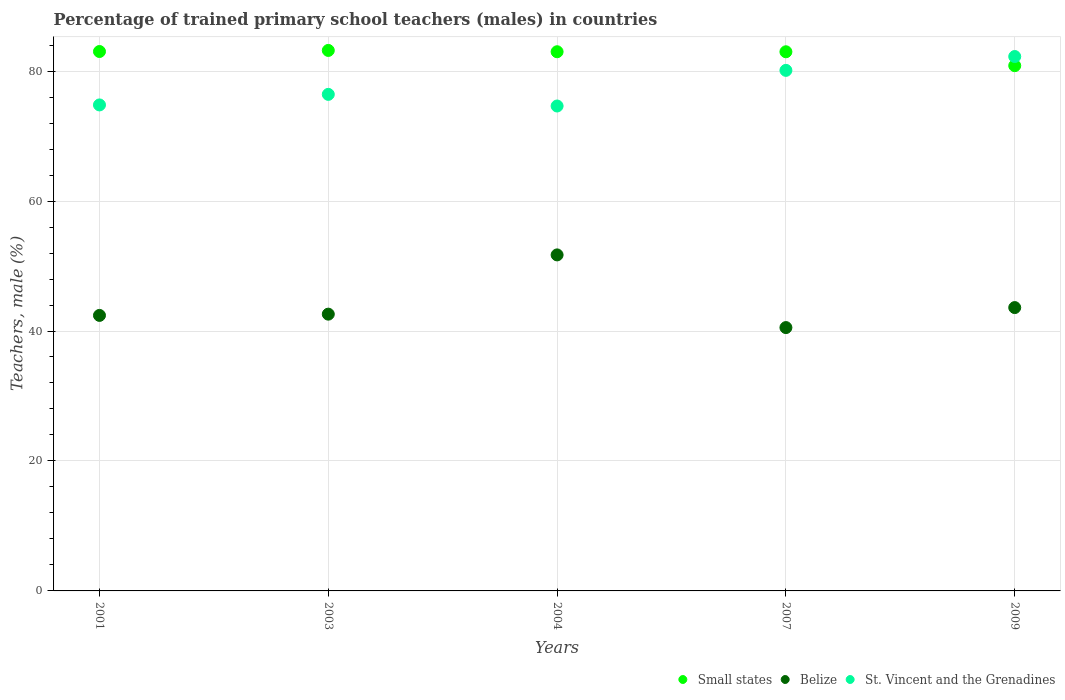Is the number of dotlines equal to the number of legend labels?
Your answer should be very brief. Yes. What is the percentage of trained primary school teachers (males) in Belize in 2001?
Keep it short and to the point. 42.4. Across all years, what is the maximum percentage of trained primary school teachers (males) in Belize?
Your answer should be very brief. 51.71. Across all years, what is the minimum percentage of trained primary school teachers (males) in St. Vincent and the Grenadines?
Offer a terse response. 74.63. In which year was the percentage of trained primary school teachers (males) in St. Vincent and the Grenadines maximum?
Give a very brief answer. 2009. What is the total percentage of trained primary school teachers (males) in St. Vincent and the Grenadines in the graph?
Your answer should be very brief. 388.19. What is the difference between the percentage of trained primary school teachers (males) in Small states in 2003 and that in 2007?
Your response must be concise. 0.21. What is the difference between the percentage of trained primary school teachers (males) in St. Vincent and the Grenadines in 2003 and the percentage of trained primary school teachers (males) in Belize in 2007?
Your response must be concise. 35.89. What is the average percentage of trained primary school teachers (males) in Small states per year?
Offer a terse response. 82.6. In the year 2003, what is the difference between the percentage of trained primary school teachers (males) in Small states and percentage of trained primary school teachers (males) in Belize?
Your answer should be very brief. 40.59. What is the ratio of the percentage of trained primary school teachers (males) in Small states in 2004 to that in 2009?
Ensure brevity in your answer.  1.03. Is the difference between the percentage of trained primary school teachers (males) in Small states in 2003 and 2004 greater than the difference between the percentage of trained primary school teachers (males) in Belize in 2003 and 2004?
Your answer should be compact. Yes. What is the difference between the highest and the second highest percentage of trained primary school teachers (males) in Belize?
Offer a terse response. 8.11. What is the difference between the highest and the lowest percentage of trained primary school teachers (males) in Belize?
Provide a short and direct response. 11.19. In how many years, is the percentage of trained primary school teachers (males) in Small states greater than the average percentage of trained primary school teachers (males) in Small states taken over all years?
Provide a short and direct response. 4. Is the percentage of trained primary school teachers (males) in Small states strictly greater than the percentage of trained primary school teachers (males) in Belize over the years?
Keep it short and to the point. Yes. How many dotlines are there?
Offer a very short reply. 3. How many years are there in the graph?
Keep it short and to the point. 5. What is the difference between two consecutive major ticks on the Y-axis?
Give a very brief answer. 20. What is the title of the graph?
Keep it short and to the point. Percentage of trained primary school teachers (males) in countries. What is the label or title of the X-axis?
Provide a succinct answer. Years. What is the label or title of the Y-axis?
Ensure brevity in your answer.  Teachers, male (%). What is the Teachers, male (%) in Small states in 2001?
Make the answer very short. 83.01. What is the Teachers, male (%) of Belize in 2001?
Your answer should be compact. 42.4. What is the Teachers, male (%) of St. Vincent and the Grenadines in 2001?
Ensure brevity in your answer.  74.79. What is the Teachers, male (%) of Small states in 2003?
Offer a very short reply. 83.18. What is the Teachers, male (%) in Belize in 2003?
Make the answer very short. 42.59. What is the Teachers, male (%) of St. Vincent and the Grenadines in 2003?
Make the answer very short. 76.42. What is the Teachers, male (%) of Small states in 2004?
Keep it short and to the point. 82.98. What is the Teachers, male (%) of Belize in 2004?
Make the answer very short. 51.71. What is the Teachers, male (%) in St. Vincent and the Grenadines in 2004?
Provide a succinct answer. 74.63. What is the Teachers, male (%) in Small states in 2007?
Provide a short and direct response. 82.97. What is the Teachers, male (%) in Belize in 2007?
Keep it short and to the point. 40.53. What is the Teachers, male (%) of St. Vincent and the Grenadines in 2007?
Give a very brief answer. 80.11. What is the Teachers, male (%) of Small states in 2009?
Your response must be concise. 80.84. What is the Teachers, male (%) in Belize in 2009?
Make the answer very short. 43.6. What is the Teachers, male (%) of St. Vincent and the Grenadines in 2009?
Provide a short and direct response. 82.24. Across all years, what is the maximum Teachers, male (%) of Small states?
Provide a short and direct response. 83.18. Across all years, what is the maximum Teachers, male (%) in Belize?
Your answer should be very brief. 51.71. Across all years, what is the maximum Teachers, male (%) in St. Vincent and the Grenadines?
Your answer should be very brief. 82.24. Across all years, what is the minimum Teachers, male (%) of Small states?
Offer a very short reply. 80.84. Across all years, what is the minimum Teachers, male (%) of Belize?
Your response must be concise. 40.53. Across all years, what is the minimum Teachers, male (%) of St. Vincent and the Grenadines?
Your response must be concise. 74.63. What is the total Teachers, male (%) in Small states in the graph?
Your answer should be compact. 412.98. What is the total Teachers, male (%) of Belize in the graph?
Make the answer very short. 220.84. What is the total Teachers, male (%) in St. Vincent and the Grenadines in the graph?
Make the answer very short. 388.19. What is the difference between the Teachers, male (%) of Small states in 2001 and that in 2003?
Ensure brevity in your answer.  -0.17. What is the difference between the Teachers, male (%) in Belize in 2001 and that in 2003?
Your answer should be compact. -0.19. What is the difference between the Teachers, male (%) in St. Vincent and the Grenadines in 2001 and that in 2003?
Your answer should be very brief. -1.62. What is the difference between the Teachers, male (%) of Small states in 2001 and that in 2004?
Your answer should be very brief. 0.04. What is the difference between the Teachers, male (%) of Belize in 2001 and that in 2004?
Give a very brief answer. -9.31. What is the difference between the Teachers, male (%) of St. Vincent and the Grenadines in 2001 and that in 2004?
Offer a very short reply. 0.17. What is the difference between the Teachers, male (%) in Small states in 2001 and that in 2007?
Provide a succinct answer. 0.04. What is the difference between the Teachers, male (%) in Belize in 2001 and that in 2007?
Offer a very short reply. 1.87. What is the difference between the Teachers, male (%) of St. Vincent and the Grenadines in 2001 and that in 2007?
Make the answer very short. -5.32. What is the difference between the Teachers, male (%) of Small states in 2001 and that in 2009?
Keep it short and to the point. 2.18. What is the difference between the Teachers, male (%) of Belize in 2001 and that in 2009?
Your answer should be very brief. -1.2. What is the difference between the Teachers, male (%) of St. Vincent and the Grenadines in 2001 and that in 2009?
Make the answer very short. -7.45. What is the difference between the Teachers, male (%) in Small states in 2003 and that in 2004?
Ensure brevity in your answer.  0.2. What is the difference between the Teachers, male (%) of Belize in 2003 and that in 2004?
Ensure brevity in your answer.  -9.12. What is the difference between the Teachers, male (%) of St. Vincent and the Grenadines in 2003 and that in 2004?
Give a very brief answer. 1.79. What is the difference between the Teachers, male (%) of Small states in 2003 and that in 2007?
Keep it short and to the point. 0.21. What is the difference between the Teachers, male (%) of Belize in 2003 and that in 2007?
Your response must be concise. 2.07. What is the difference between the Teachers, male (%) in St. Vincent and the Grenadines in 2003 and that in 2007?
Offer a terse response. -3.69. What is the difference between the Teachers, male (%) in Small states in 2003 and that in 2009?
Offer a terse response. 2.34. What is the difference between the Teachers, male (%) in Belize in 2003 and that in 2009?
Your response must be concise. -1.01. What is the difference between the Teachers, male (%) in St. Vincent and the Grenadines in 2003 and that in 2009?
Provide a short and direct response. -5.82. What is the difference between the Teachers, male (%) in Small states in 2004 and that in 2007?
Your response must be concise. 0. What is the difference between the Teachers, male (%) of Belize in 2004 and that in 2007?
Make the answer very short. 11.19. What is the difference between the Teachers, male (%) of St. Vincent and the Grenadines in 2004 and that in 2007?
Offer a very short reply. -5.48. What is the difference between the Teachers, male (%) of Small states in 2004 and that in 2009?
Offer a very short reply. 2.14. What is the difference between the Teachers, male (%) in Belize in 2004 and that in 2009?
Make the answer very short. 8.11. What is the difference between the Teachers, male (%) of St. Vincent and the Grenadines in 2004 and that in 2009?
Your answer should be very brief. -7.61. What is the difference between the Teachers, male (%) in Small states in 2007 and that in 2009?
Make the answer very short. 2.14. What is the difference between the Teachers, male (%) of Belize in 2007 and that in 2009?
Ensure brevity in your answer.  -3.08. What is the difference between the Teachers, male (%) of St. Vincent and the Grenadines in 2007 and that in 2009?
Make the answer very short. -2.13. What is the difference between the Teachers, male (%) of Small states in 2001 and the Teachers, male (%) of Belize in 2003?
Make the answer very short. 40.42. What is the difference between the Teachers, male (%) in Small states in 2001 and the Teachers, male (%) in St. Vincent and the Grenadines in 2003?
Give a very brief answer. 6.6. What is the difference between the Teachers, male (%) in Belize in 2001 and the Teachers, male (%) in St. Vincent and the Grenadines in 2003?
Offer a very short reply. -34.02. What is the difference between the Teachers, male (%) of Small states in 2001 and the Teachers, male (%) of Belize in 2004?
Your response must be concise. 31.3. What is the difference between the Teachers, male (%) in Small states in 2001 and the Teachers, male (%) in St. Vincent and the Grenadines in 2004?
Ensure brevity in your answer.  8.39. What is the difference between the Teachers, male (%) of Belize in 2001 and the Teachers, male (%) of St. Vincent and the Grenadines in 2004?
Keep it short and to the point. -32.23. What is the difference between the Teachers, male (%) in Small states in 2001 and the Teachers, male (%) in Belize in 2007?
Give a very brief answer. 42.49. What is the difference between the Teachers, male (%) of Small states in 2001 and the Teachers, male (%) of St. Vincent and the Grenadines in 2007?
Offer a very short reply. 2.9. What is the difference between the Teachers, male (%) in Belize in 2001 and the Teachers, male (%) in St. Vincent and the Grenadines in 2007?
Provide a succinct answer. -37.71. What is the difference between the Teachers, male (%) of Small states in 2001 and the Teachers, male (%) of Belize in 2009?
Make the answer very short. 39.41. What is the difference between the Teachers, male (%) in Small states in 2001 and the Teachers, male (%) in St. Vincent and the Grenadines in 2009?
Ensure brevity in your answer.  0.77. What is the difference between the Teachers, male (%) in Belize in 2001 and the Teachers, male (%) in St. Vincent and the Grenadines in 2009?
Keep it short and to the point. -39.84. What is the difference between the Teachers, male (%) of Small states in 2003 and the Teachers, male (%) of Belize in 2004?
Provide a short and direct response. 31.47. What is the difference between the Teachers, male (%) in Small states in 2003 and the Teachers, male (%) in St. Vincent and the Grenadines in 2004?
Your answer should be very brief. 8.55. What is the difference between the Teachers, male (%) of Belize in 2003 and the Teachers, male (%) of St. Vincent and the Grenadines in 2004?
Your response must be concise. -32.03. What is the difference between the Teachers, male (%) in Small states in 2003 and the Teachers, male (%) in Belize in 2007?
Your answer should be compact. 42.65. What is the difference between the Teachers, male (%) of Small states in 2003 and the Teachers, male (%) of St. Vincent and the Grenadines in 2007?
Your answer should be very brief. 3.07. What is the difference between the Teachers, male (%) of Belize in 2003 and the Teachers, male (%) of St. Vincent and the Grenadines in 2007?
Provide a succinct answer. -37.52. What is the difference between the Teachers, male (%) of Small states in 2003 and the Teachers, male (%) of Belize in 2009?
Keep it short and to the point. 39.57. What is the difference between the Teachers, male (%) of Small states in 2003 and the Teachers, male (%) of St. Vincent and the Grenadines in 2009?
Give a very brief answer. 0.94. What is the difference between the Teachers, male (%) in Belize in 2003 and the Teachers, male (%) in St. Vincent and the Grenadines in 2009?
Give a very brief answer. -39.65. What is the difference between the Teachers, male (%) of Small states in 2004 and the Teachers, male (%) of Belize in 2007?
Your answer should be compact. 42.45. What is the difference between the Teachers, male (%) in Small states in 2004 and the Teachers, male (%) in St. Vincent and the Grenadines in 2007?
Your answer should be very brief. 2.87. What is the difference between the Teachers, male (%) of Belize in 2004 and the Teachers, male (%) of St. Vincent and the Grenadines in 2007?
Ensure brevity in your answer.  -28.4. What is the difference between the Teachers, male (%) in Small states in 2004 and the Teachers, male (%) in Belize in 2009?
Ensure brevity in your answer.  39.37. What is the difference between the Teachers, male (%) of Small states in 2004 and the Teachers, male (%) of St. Vincent and the Grenadines in 2009?
Provide a succinct answer. 0.74. What is the difference between the Teachers, male (%) in Belize in 2004 and the Teachers, male (%) in St. Vincent and the Grenadines in 2009?
Provide a succinct answer. -30.53. What is the difference between the Teachers, male (%) of Small states in 2007 and the Teachers, male (%) of Belize in 2009?
Ensure brevity in your answer.  39.37. What is the difference between the Teachers, male (%) in Small states in 2007 and the Teachers, male (%) in St. Vincent and the Grenadines in 2009?
Ensure brevity in your answer.  0.73. What is the difference between the Teachers, male (%) in Belize in 2007 and the Teachers, male (%) in St. Vincent and the Grenadines in 2009?
Offer a very short reply. -41.71. What is the average Teachers, male (%) in Small states per year?
Make the answer very short. 82.6. What is the average Teachers, male (%) in Belize per year?
Make the answer very short. 44.17. What is the average Teachers, male (%) of St. Vincent and the Grenadines per year?
Offer a terse response. 77.64. In the year 2001, what is the difference between the Teachers, male (%) in Small states and Teachers, male (%) in Belize?
Your answer should be compact. 40.61. In the year 2001, what is the difference between the Teachers, male (%) in Small states and Teachers, male (%) in St. Vincent and the Grenadines?
Provide a succinct answer. 8.22. In the year 2001, what is the difference between the Teachers, male (%) of Belize and Teachers, male (%) of St. Vincent and the Grenadines?
Provide a short and direct response. -32.39. In the year 2003, what is the difference between the Teachers, male (%) of Small states and Teachers, male (%) of Belize?
Your answer should be compact. 40.59. In the year 2003, what is the difference between the Teachers, male (%) in Small states and Teachers, male (%) in St. Vincent and the Grenadines?
Provide a short and direct response. 6.76. In the year 2003, what is the difference between the Teachers, male (%) of Belize and Teachers, male (%) of St. Vincent and the Grenadines?
Your response must be concise. -33.82. In the year 2004, what is the difference between the Teachers, male (%) of Small states and Teachers, male (%) of Belize?
Give a very brief answer. 31.27. In the year 2004, what is the difference between the Teachers, male (%) in Small states and Teachers, male (%) in St. Vincent and the Grenadines?
Provide a short and direct response. 8.35. In the year 2004, what is the difference between the Teachers, male (%) in Belize and Teachers, male (%) in St. Vincent and the Grenadines?
Offer a terse response. -22.91. In the year 2007, what is the difference between the Teachers, male (%) in Small states and Teachers, male (%) in Belize?
Provide a succinct answer. 42.45. In the year 2007, what is the difference between the Teachers, male (%) of Small states and Teachers, male (%) of St. Vincent and the Grenadines?
Your answer should be very brief. 2.86. In the year 2007, what is the difference between the Teachers, male (%) of Belize and Teachers, male (%) of St. Vincent and the Grenadines?
Keep it short and to the point. -39.58. In the year 2009, what is the difference between the Teachers, male (%) in Small states and Teachers, male (%) in Belize?
Your answer should be compact. 37.23. In the year 2009, what is the difference between the Teachers, male (%) in Small states and Teachers, male (%) in St. Vincent and the Grenadines?
Ensure brevity in your answer.  -1.41. In the year 2009, what is the difference between the Teachers, male (%) of Belize and Teachers, male (%) of St. Vincent and the Grenadines?
Your answer should be compact. -38.64. What is the ratio of the Teachers, male (%) of Belize in 2001 to that in 2003?
Keep it short and to the point. 1. What is the ratio of the Teachers, male (%) of St. Vincent and the Grenadines in 2001 to that in 2003?
Your answer should be very brief. 0.98. What is the ratio of the Teachers, male (%) of Belize in 2001 to that in 2004?
Offer a very short reply. 0.82. What is the ratio of the Teachers, male (%) in Belize in 2001 to that in 2007?
Offer a very short reply. 1.05. What is the ratio of the Teachers, male (%) of St. Vincent and the Grenadines in 2001 to that in 2007?
Provide a succinct answer. 0.93. What is the ratio of the Teachers, male (%) in Small states in 2001 to that in 2009?
Offer a terse response. 1.03. What is the ratio of the Teachers, male (%) in Belize in 2001 to that in 2009?
Ensure brevity in your answer.  0.97. What is the ratio of the Teachers, male (%) in St. Vincent and the Grenadines in 2001 to that in 2009?
Make the answer very short. 0.91. What is the ratio of the Teachers, male (%) of Belize in 2003 to that in 2004?
Your answer should be compact. 0.82. What is the ratio of the Teachers, male (%) in Belize in 2003 to that in 2007?
Provide a succinct answer. 1.05. What is the ratio of the Teachers, male (%) of St. Vincent and the Grenadines in 2003 to that in 2007?
Your answer should be very brief. 0.95. What is the ratio of the Teachers, male (%) in Small states in 2003 to that in 2009?
Ensure brevity in your answer.  1.03. What is the ratio of the Teachers, male (%) in Belize in 2003 to that in 2009?
Provide a succinct answer. 0.98. What is the ratio of the Teachers, male (%) of St. Vincent and the Grenadines in 2003 to that in 2009?
Provide a short and direct response. 0.93. What is the ratio of the Teachers, male (%) in Belize in 2004 to that in 2007?
Offer a terse response. 1.28. What is the ratio of the Teachers, male (%) of St. Vincent and the Grenadines in 2004 to that in 2007?
Offer a very short reply. 0.93. What is the ratio of the Teachers, male (%) in Small states in 2004 to that in 2009?
Make the answer very short. 1.03. What is the ratio of the Teachers, male (%) of Belize in 2004 to that in 2009?
Your answer should be compact. 1.19. What is the ratio of the Teachers, male (%) of St. Vincent and the Grenadines in 2004 to that in 2009?
Offer a terse response. 0.91. What is the ratio of the Teachers, male (%) in Small states in 2007 to that in 2009?
Your response must be concise. 1.03. What is the ratio of the Teachers, male (%) of Belize in 2007 to that in 2009?
Give a very brief answer. 0.93. What is the ratio of the Teachers, male (%) of St. Vincent and the Grenadines in 2007 to that in 2009?
Your answer should be very brief. 0.97. What is the difference between the highest and the second highest Teachers, male (%) in Small states?
Ensure brevity in your answer.  0.17. What is the difference between the highest and the second highest Teachers, male (%) in Belize?
Make the answer very short. 8.11. What is the difference between the highest and the second highest Teachers, male (%) in St. Vincent and the Grenadines?
Ensure brevity in your answer.  2.13. What is the difference between the highest and the lowest Teachers, male (%) in Small states?
Give a very brief answer. 2.34. What is the difference between the highest and the lowest Teachers, male (%) of Belize?
Your response must be concise. 11.19. What is the difference between the highest and the lowest Teachers, male (%) in St. Vincent and the Grenadines?
Your answer should be compact. 7.61. 